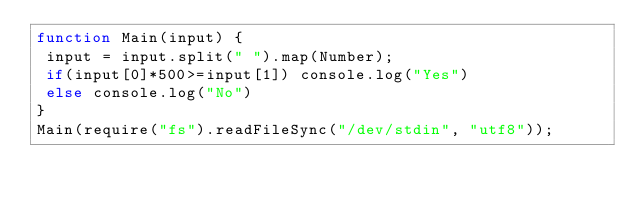<code> <loc_0><loc_0><loc_500><loc_500><_JavaScript_>function Main(input) {
 input = input.split(" ").map(Number);
 if(input[0]*500>=input[1]) console.log("Yes")
 else console.log("No")
}
Main(require("fs").readFileSync("/dev/stdin", "utf8"));</code> 